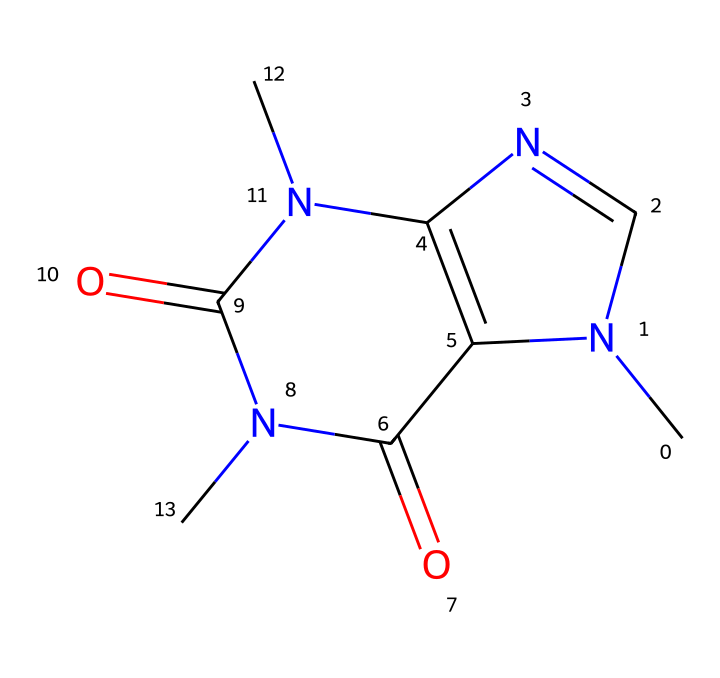What is the molecular formula of caffeine? To find the molecular formula, count the number of each type of atom in the SMILES representation. The breakdown shows that there are 8 carbon (C) atoms, 10 hydrogen (H) atoms, 4 nitrogen (N) atoms, and 2 oxygen (O) atoms. Thus, the molecular formula is C8H10N4O2.
Answer: C8H10N4O2 How many nitrogen atoms are present in caffeine? By analyzing the SMILES structure, we can find that there are four occurrences of nitrogen (N) in the representation. Therefore, the answer is four.
Answer: four What type of compound is caffeine classified as? Caffeine is classified as a xanthine alkaloid due to its structure containing a xanthine skeleton and its pharmacological properties. This classification arises from the arrangement of nitrogen and carbon in the structure.
Answer: xanthine alkaloid What is the number of rings in the structure of caffeine? Upon examining the chemical structure, you can observe two fused rings. This can be identified by observing how the nitrogen and carbon atoms connect. The rings are typical in many alkaloids, including caffeine.
Answer: two Which functional groups are present in caffeine? By examining the structure, we can identify functional groups such as amine (–NH) and carbonyl (C=O) groups. The presence of these specific groups affects the compound's reactivity and properties.
Answer: amine and carbonyl What is the primary pharmacological effect of caffeine? The primary effect of caffeine is stimulation of the central nervous system, leading to increased alertness and reduced fatigue. This is inferred from its classification as a stimulant and its common use in coffee and energy drinks.
Answer: stimulation 